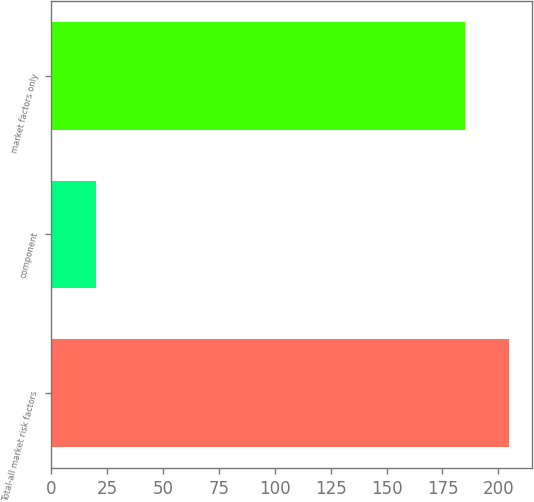Convert chart to OTSL. <chart><loc_0><loc_0><loc_500><loc_500><bar_chart><fcel>Total-all market risk factors<fcel>component<fcel>market factors only<nl><fcel>205<fcel>20<fcel>185<nl></chart> 